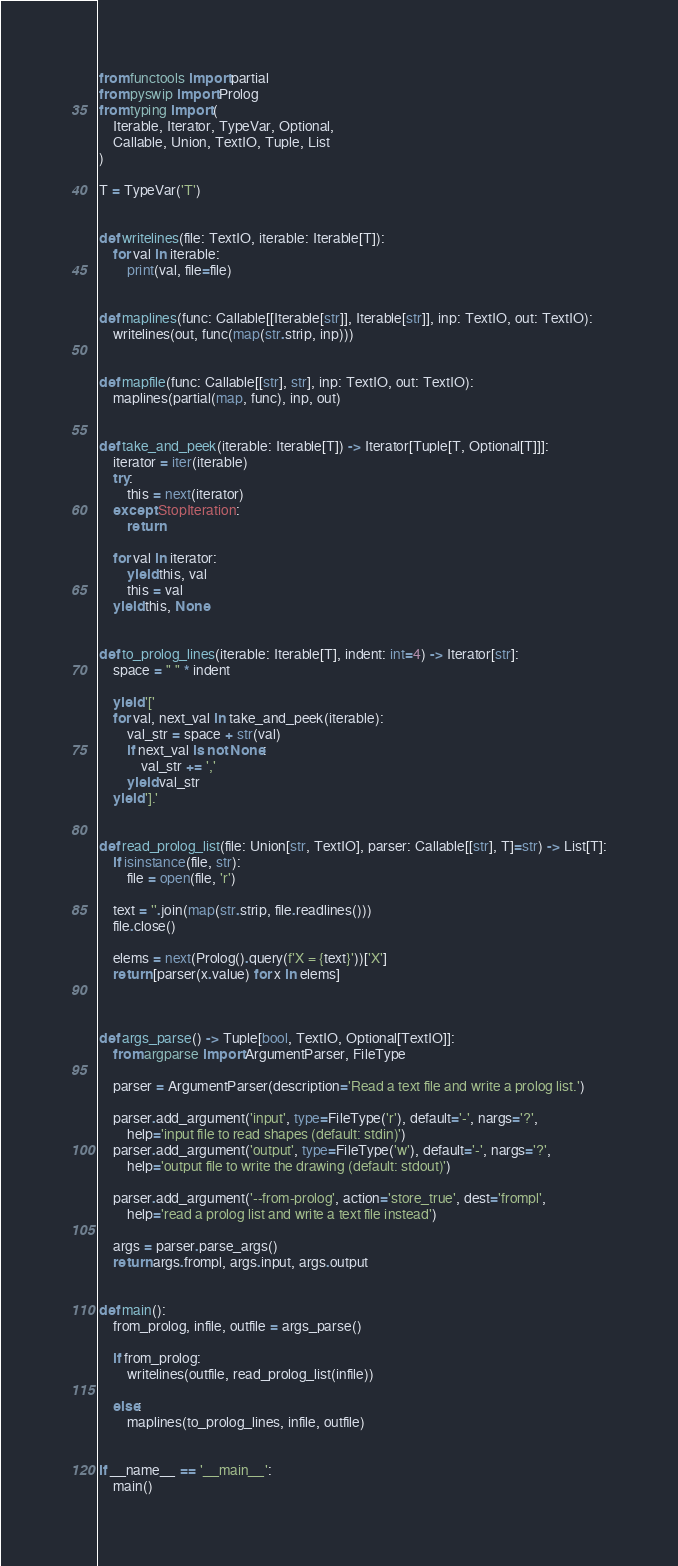<code> <loc_0><loc_0><loc_500><loc_500><_Python_>from functools import partial
from pyswip import Prolog
from typing import (
    Iterable, Iterator, TypeVar, Optional,
    Callable, Union, TextIO, Tuple, List
)

T = TypeVar('T')


def writelines(file: TextIO, iterable: Iterable[T]):
    for val in iterable:
        print(val, file=file)


def maplines(func: Callable[[Iterable[str]], Iterable[str]], inp: TextIO, out: TextIO):
    writelines(out, func(map(str.strip, inp)))


def mapfile(func: Callable[[str], str], inp: TextIO, out: TextIO):
    maplines(partial(map, func), inp, out)


def take_and_peek(iterable: Iterable[T]) -> Iterator[Tuple[T, Optional[T]]]:
    iterator = iter(iterable)
    try:
        this = next(iterator)
    except StopIteration:
        return

    for val in iterator:
        yield this, val
        this = val
    yield this, None


def to_prolog_lines(iterable: Iterable[T], indent: int=4) -> Iterator[str]:
    space = " " * indent

    yield '['
    for val, next_val in take_and_peek(iterable):
        val_str = space + str(val)
        if next_val is not None:
            val_str += ','
        yield val_str
    yield '].'


def read_prolog_list(file: Union[str, TextIO], parser: Callable[[str], T]=str) -> List[T]:
    if isinstance(file, str):
        file = open(file, 'r')

    text = ''.join(map(str.strip, file.readlines()))
    file.close()

    elems = next(Prolog().query(f'X = {text}'))['X']
    return [parser(x.value) for x in elems]



def args_parse() -> Tuple[bool, TextIO, Optional[TextIO]]:
    from argparse import ArgumentParser, FileType

    parser = ArgumentParser(description='Read a text file and write a prolog list.')

    parser.add_argument('input', type=FileType('r'), default='-', nargs='?',
        help='input file to read shapes (default: stdin)')
    parser.add_argument('output', type=FileType('w'), default='-', nargs='?',
        help='output file to write the drawing (default: stdout)')

    parser.add_argument('--from-prolog', action='store_true', dest='frompl',
        help='read a prolog list and write a text file instead')

    args = parser.parse_args()
    return args.frompl, args.input, args.output


def main():
    from_prolog, infile, outfile = args_parse()

    if from_prolog:
        writelines(outfile, read_prolog_list(infile))

    else:
        maplines(to_prolog_lines, infile, outfile)


if __name__ == '__main__':
    main()
</code> 